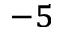Convert formula to latex. <formula><loc_0><loc_0><loc_500><loc_500>^ { - 5 }</formula> 